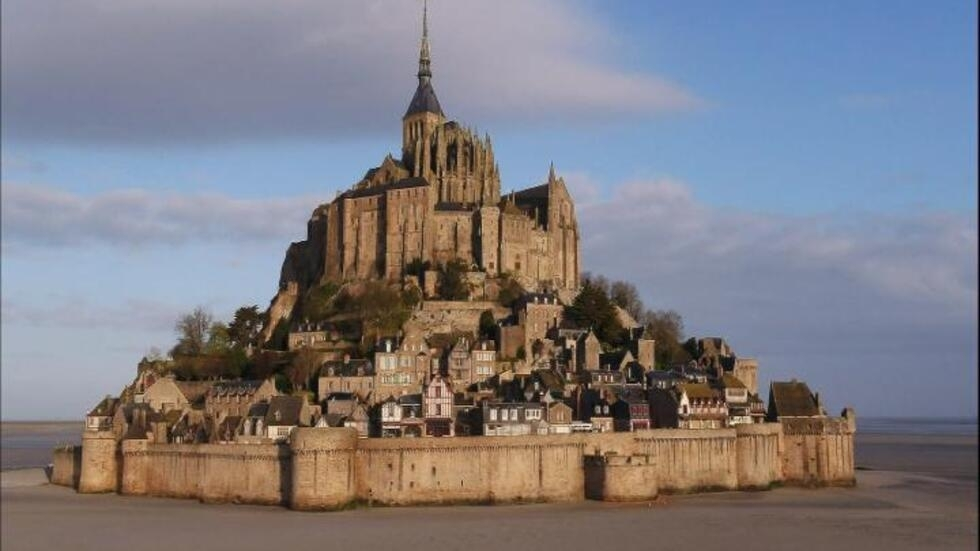What other features of Mont Saint-Michel are often overlooked by visitors? While the abbey is the star attraction, Mont Saint-Michel has several lesser-known features that are equally captivating. For instance, the island is home to a network of narrow alleyways and hidden passages, some leading to stunning viewpoints or secret gardens. The small, yet fascinating museums, like the Archaeoscope, offer interactive exhibits about the island’s history and construction. Another overlooked feature is the natural beauty of the surrounding tidal flats. During low tide, guided walks across the sands reveal fascinating marine life and the unique ecosystem of the area. Additionally, the ancient cemetery near the abbey is a quiet and reflective spot that offers a glimpse into the lives of past residents. These often-overlooked aspects add depth and richness to any visit, making Mont Saint-Michel much more than just its famous abbey. Let's be creative: Imagine Mont Saint-Michel is a spaceship ready for interstellar travel. Describe its launch. Amidst a swirl of futuristic technology and historical grandeur, Mont Saint-Michel is transformed into a colossal spaceship. As night falls, the ancient stones of the abbey glow with a soft, ethereal light, hinting at the hidden power within. Pilgrims and villagers gather in awe as robotic emissaries prepare the launch, their advanced machinery seamlessly blending with the medieval architecture. The fortified walls retract, revealing sleek metallic surfaces and powerful thrusters. Suddenly, a deep rumble resonates through the island, and the towering spire emits beams of radiant light, piercing the night sky. The tidal flats shimmer as anti-gravity fields activate, lifting Mont Saint-Michel gently into the air. With a final, thunderous roar, the spaceship surges upward, leaving a trail of golden stardust in its wake. As it ascends to the cosmos, the island-turned-vessel becomes a beacon of hope and exploration, carrying the legacy of human ingenuity and history into the vastness of space. 